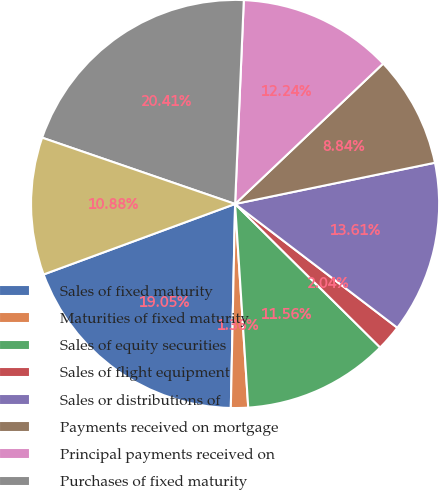Convert chart. <chart><loc_0><loc_0><loc_500><loc_500><pie_chart><fcel>Sales of fixed maturity<fcel>Maturities of fixed maturity<fcel>Sales of equity securities<fcel>Sales of flight equipment<fcel>Sales or distributions of<fcel>Payments received on mortgage<fcel>Principal payments received on<fcel>Purchases of fixed maturity<fcel>Purchases of equity securities<nl><fcel>19.05%<fcel>1.36%<fcel>11.56%<fcel>2.04%<fcel>13.61%<fcel>8.84%<fcel>12.24%<fcel>20.41%<fcel>10.88%<nl></chart> 